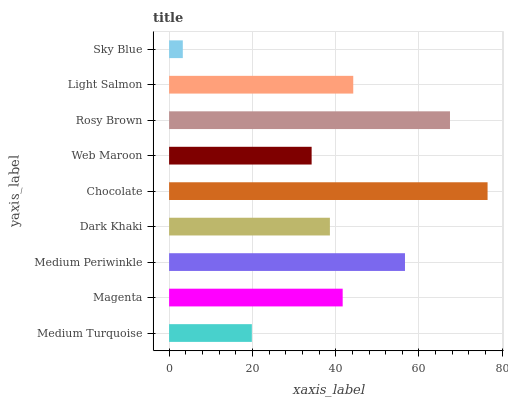Is Sky Blue the minimum?
Answer yes or no. Yes. Is Chocolate the maximum?
Answer yes or no. Yes. Is Magenta the minimum?
Answer yes or no. No. Is Magenta the maximum?
Answer yes or no. No. Is Magenta greater than Medium Turquoise?
Answer yes or no. Yes. Is Medium Turquoise less than Magenta?
Answer yes or no. Yes. Is Medium Turquoise greater than Magenta?
Answer yes or no. No. Is Magenta less than Medium Turquoise?
Answer yes or no. No. Is Magenta the high median?
Answer yes or no. Yes. Is Magenta the low median?
Answer yes or no. Yes. Is Light Salmon the high median?
Answer yes or no. No. Is Rosy Brown the low median?
Answer yes or no. No. 